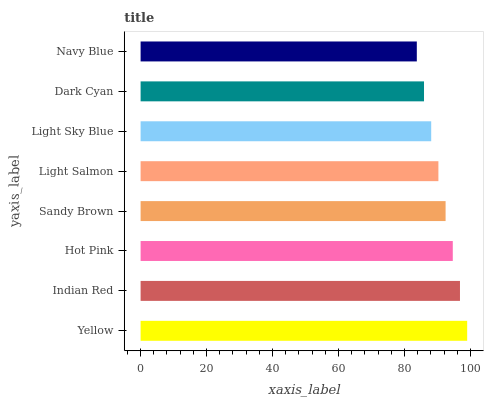Is Navy Blue the minimum?
Answer yes or no. Yes. Is Yellow the maximum?
Answer yes or no. Yes. Is Indian Red the minimum?
Answer yes or no. No. Is Indian Red the maximum?
Answer yes or no. No. Is Yellow greater than Indian Red?
Answer yes or no. Yes. Is Indian Red less than Yellow?
Answer yes or no. Yes. Is Indian Red greater than Yellow?
Answer yes or no. No. Is Yellow less than Indian Red?
Answer yes or no. No. Is Sandy Brown the high median?
Answer yes or no. Yes. Is Light Salmon the low median?
Answer yes or no. Yes. Is Light Salmon the high median?
Answer yes or no. No. Is Navy Blue the low median?
Answer yes or no. No. 